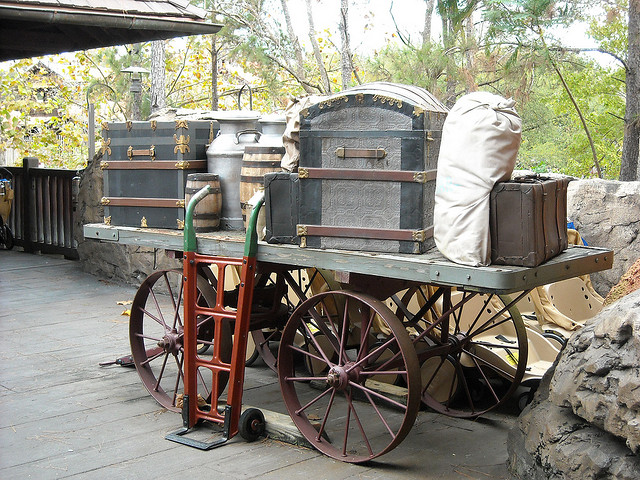What period does this wagon seem to be from? The wagon appears to be of a style that was commonly used in the late 19th to early 20th century, often associated with the Old West or pioneer era of American history. 